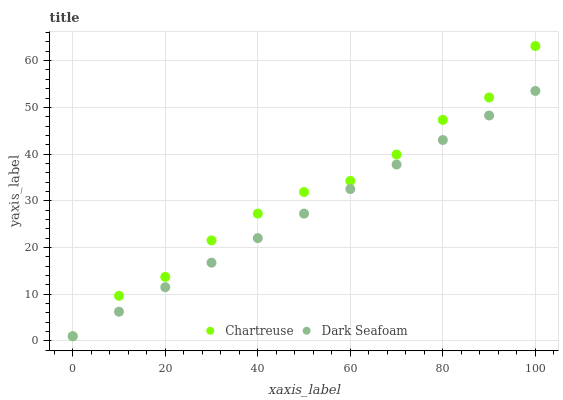Does Dark Seafoam have the minimum area under the curve?
Answer yes or no. Yes. Does Chartreuse have the maximum area under the curve?
Answer yes or no. Yes. Does Dark Seafoam have the maximum area under the curve?
Answer yes or no. No. Is Dark Seafoam the smoothest?
Answer yes or no. Yes. Is Chartreuse the roughest?
Answer yes or no. Yes. Is Dark Seafoam the roughest?
Answer yes or no. No. Does Chartreuse have the lowest value?
Answer yes or no. Yes. Does Chartreuse have the highest value?
Answer yes or no. Yes. Does Dark Seafoam have the highest value?
Answer yes or no. No. Does Dark Seafoam intersect Chartreuse?
Answer yes or no. Yes. Is Dark Seafoam less than Chartreuse?
Answer yes or no. No. Is Dark Seafoam greater than Chartreuse?
Answer yes or no. No. 